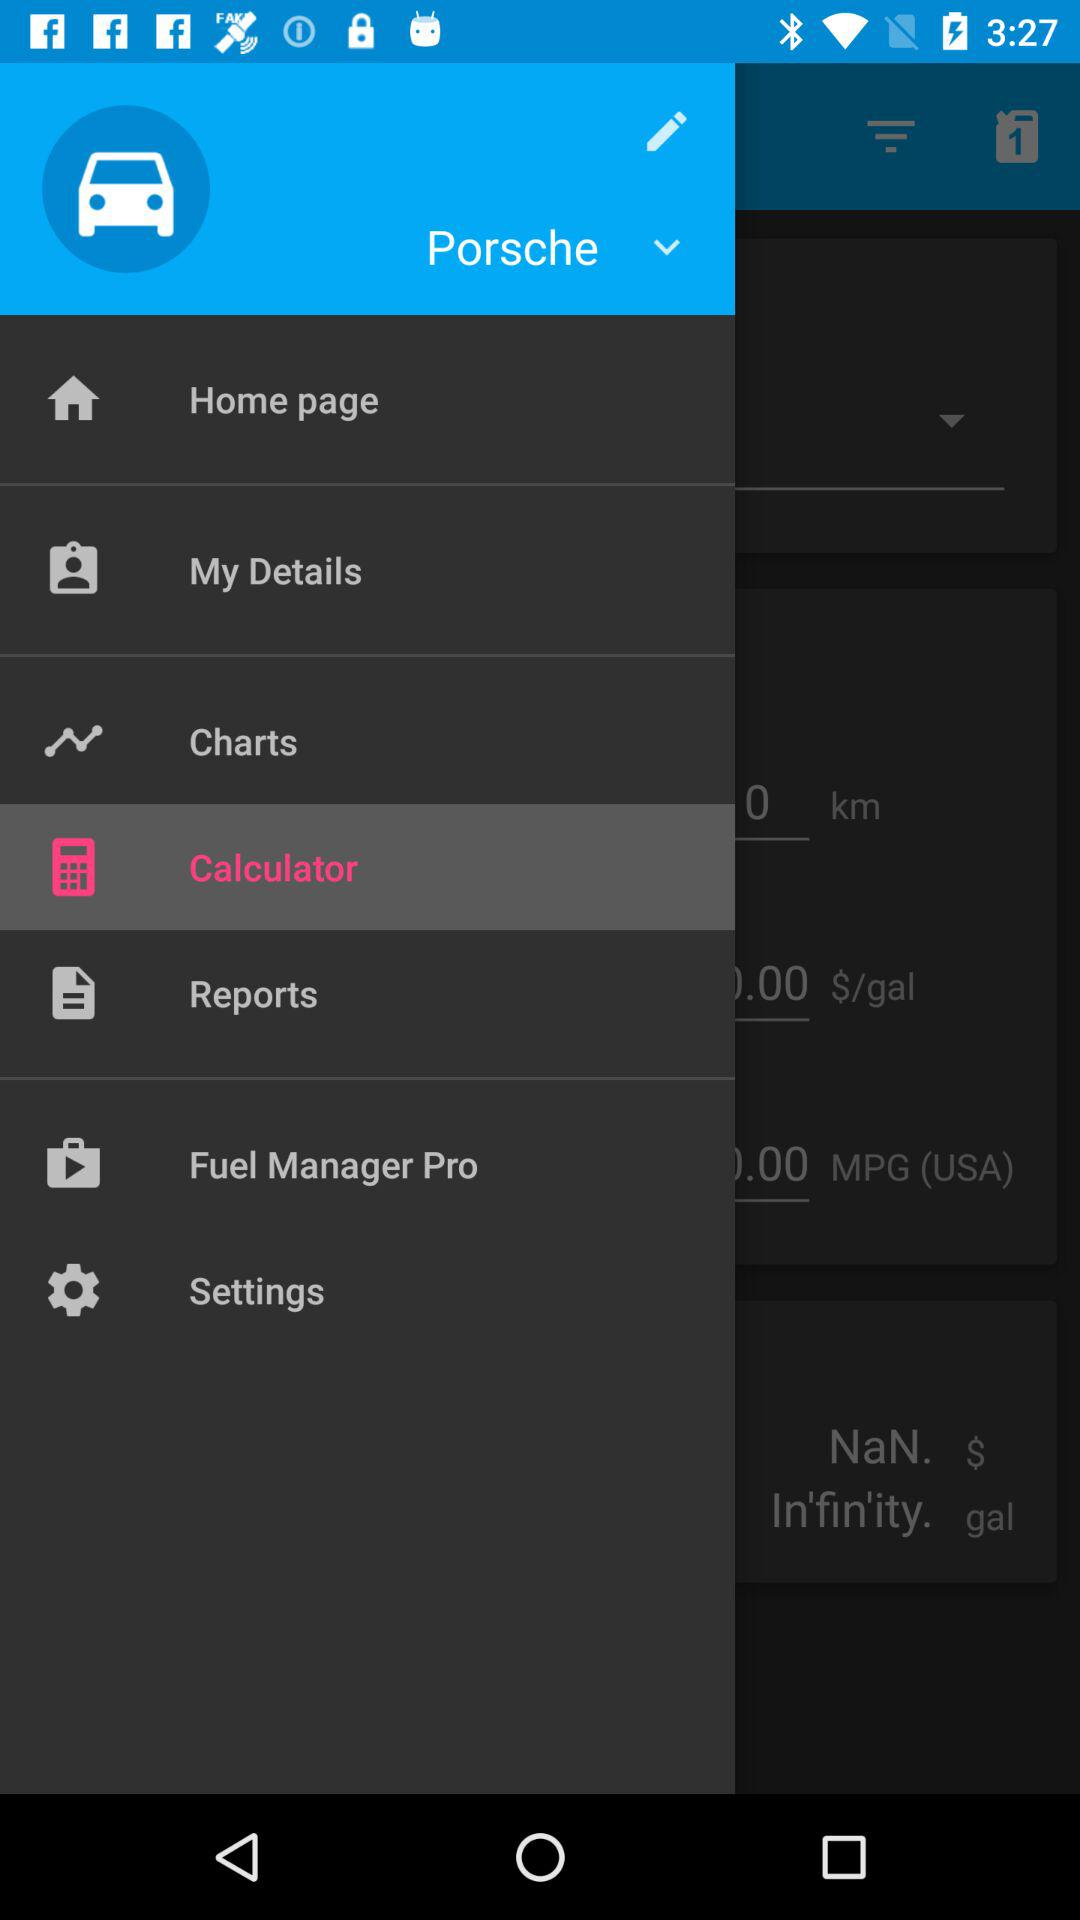How many notifications are there in "Settings"?
When the provided information is insufficient, respond with <no answer>. <no answer> 